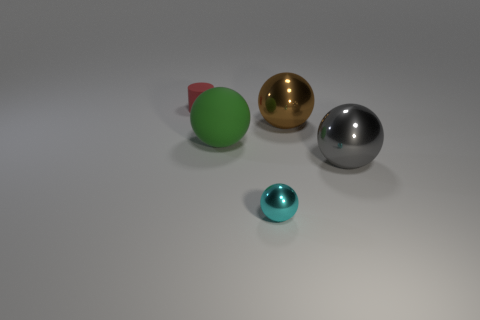Beside the shiny spheres, there's a green object. What is its shape and does it seem to have a different texture compared to the metallic spheres? The green object is a mixture of geometric shapes, closely resembling a cylinder with a hemisphere on top. Its surface is matte and less reflective, suggesting a non-metallic, possibly plastic or painted wood, material. 